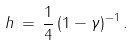<formula> <loc_0><loc_0><loc_500><loc_500>h \, = \, \frac { 1 } { 4 } \left ( 1 - \gamma \right ) ^ { - 1 } .</formula> 